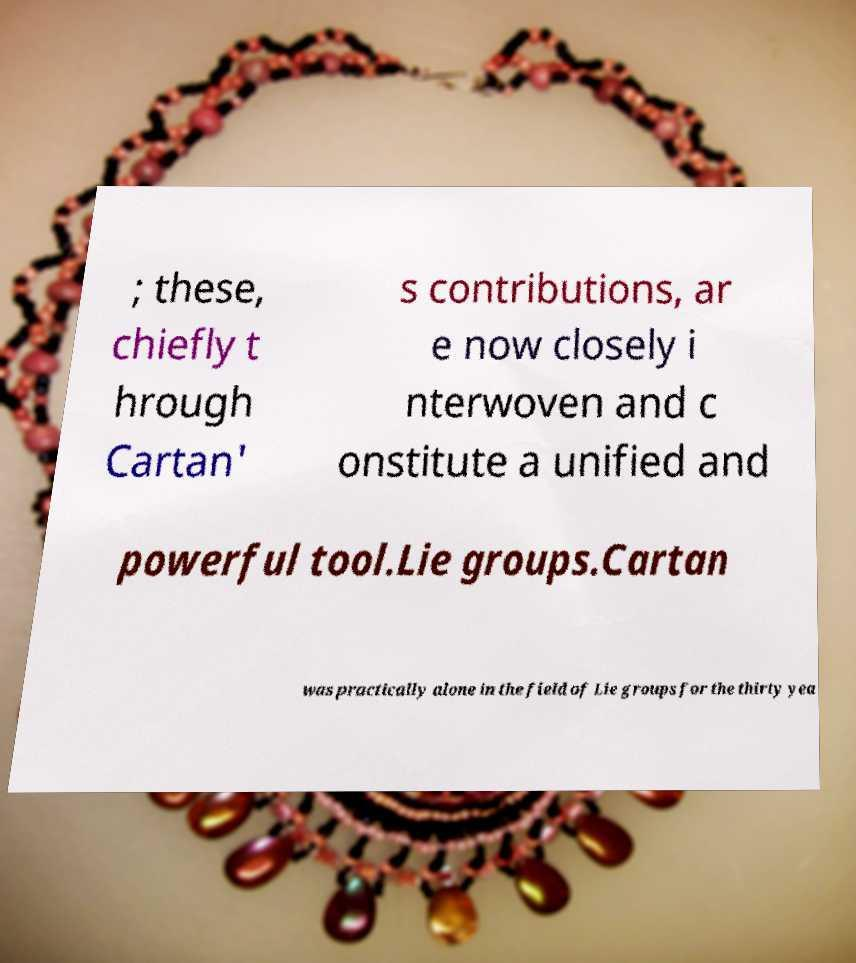There's text embedded in this image that I need extracted. Can you transcribe it verbatim? ; these, chiefly t hrough Cartan' s contributions, ar e now closely i nterwoven and c onstitute a unified and powerful tool.Lie groups.Cartan was practically alone in the field of Lie groups for the thirty yea 